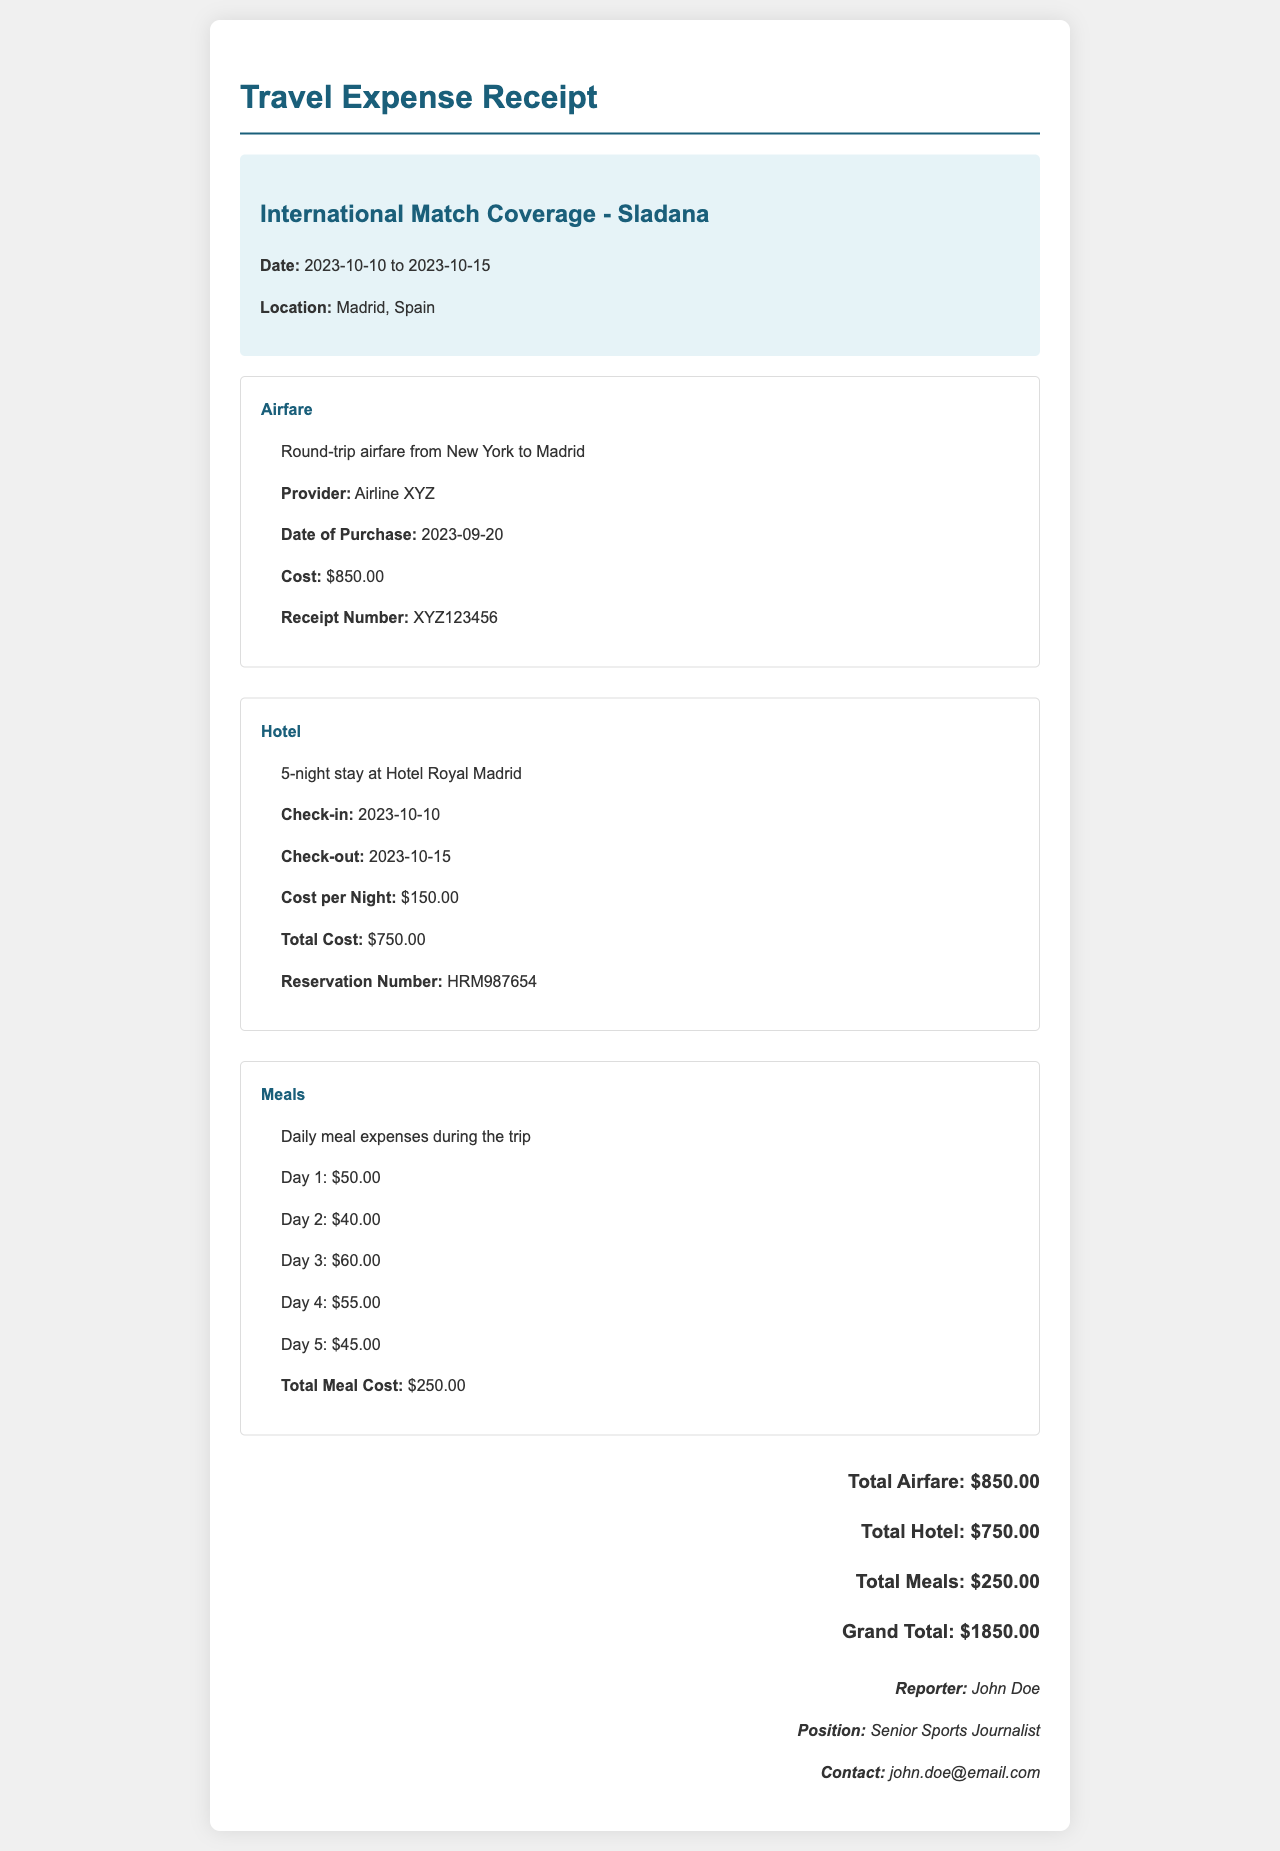What were the dates of Sladana's trip? The document indicates the trip dates as 2023-10-10 to 2023-10-15.
Answer: 2023-10-10 to 2023-10-15 Where was the match coverage located? The location specified in the document is Madrid, Spain.
Answer: Madrid, Spain What was the total cost for airfare? The total airfare cost mentioned in the document is $850.00.
Answer: $850.00 How many nights did the hotel stay last? The document shows a 5-night stay at the hotel.
Answer: 5 nights What was the total cost for meals? According to the document, the total meal cost is $250.00.
Answer: $250.00 Who was the reporter covering the match? The document names the reporter as John Doe.
Answer: John Doe What is the total grand amount of expenses? The grand total calculated in the document is $1850.00.
Answer: $1850.00 What is the reservation number for the hotel? The document provides the hotel reservation number as HRM987654.
Answer: HRM987654 What was the cost per night at the hotel? The hotel cost per night is specified as $150.00 in the document.
Answer: $150.00 